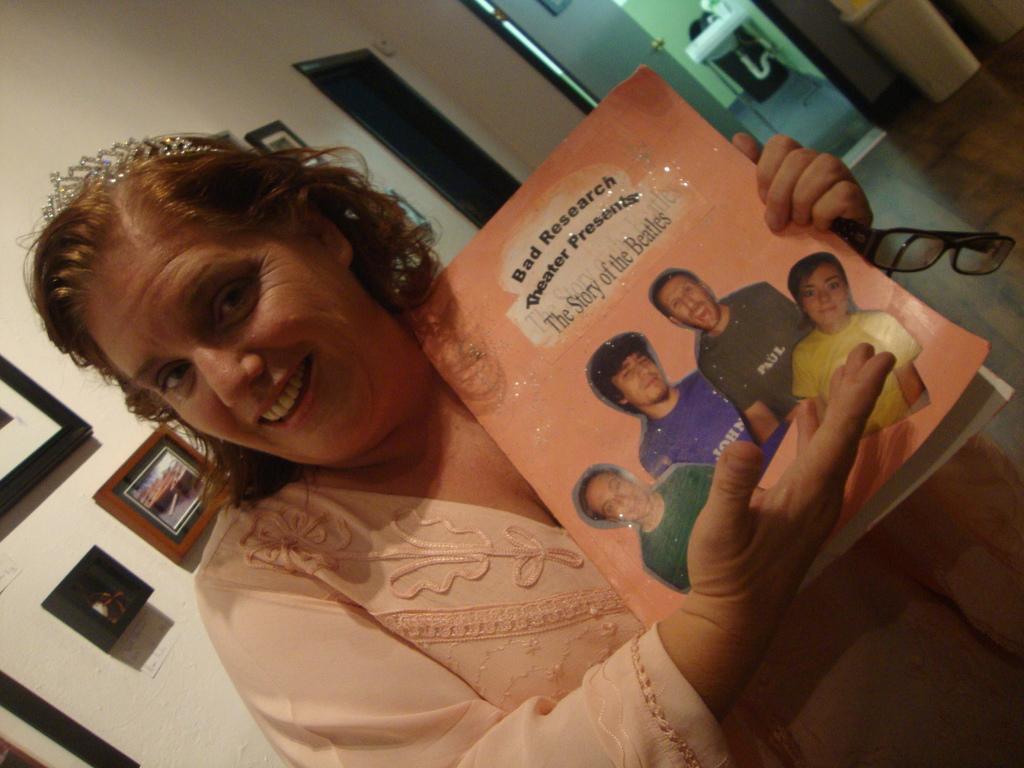In one or two sentences, can you explain what this image depicts? In this picture we can see a woman holding a book and a spectacle with her hand and smiling and in the background we can see frames, wall, doors, pipe, sink. 